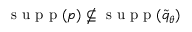<formula> <loc_0><loc_0><loc_500><loc_500>s u p p ( p ) \nsubseteq { s u p p } ( \widetilde { q } _ { \theta } )</formula> 